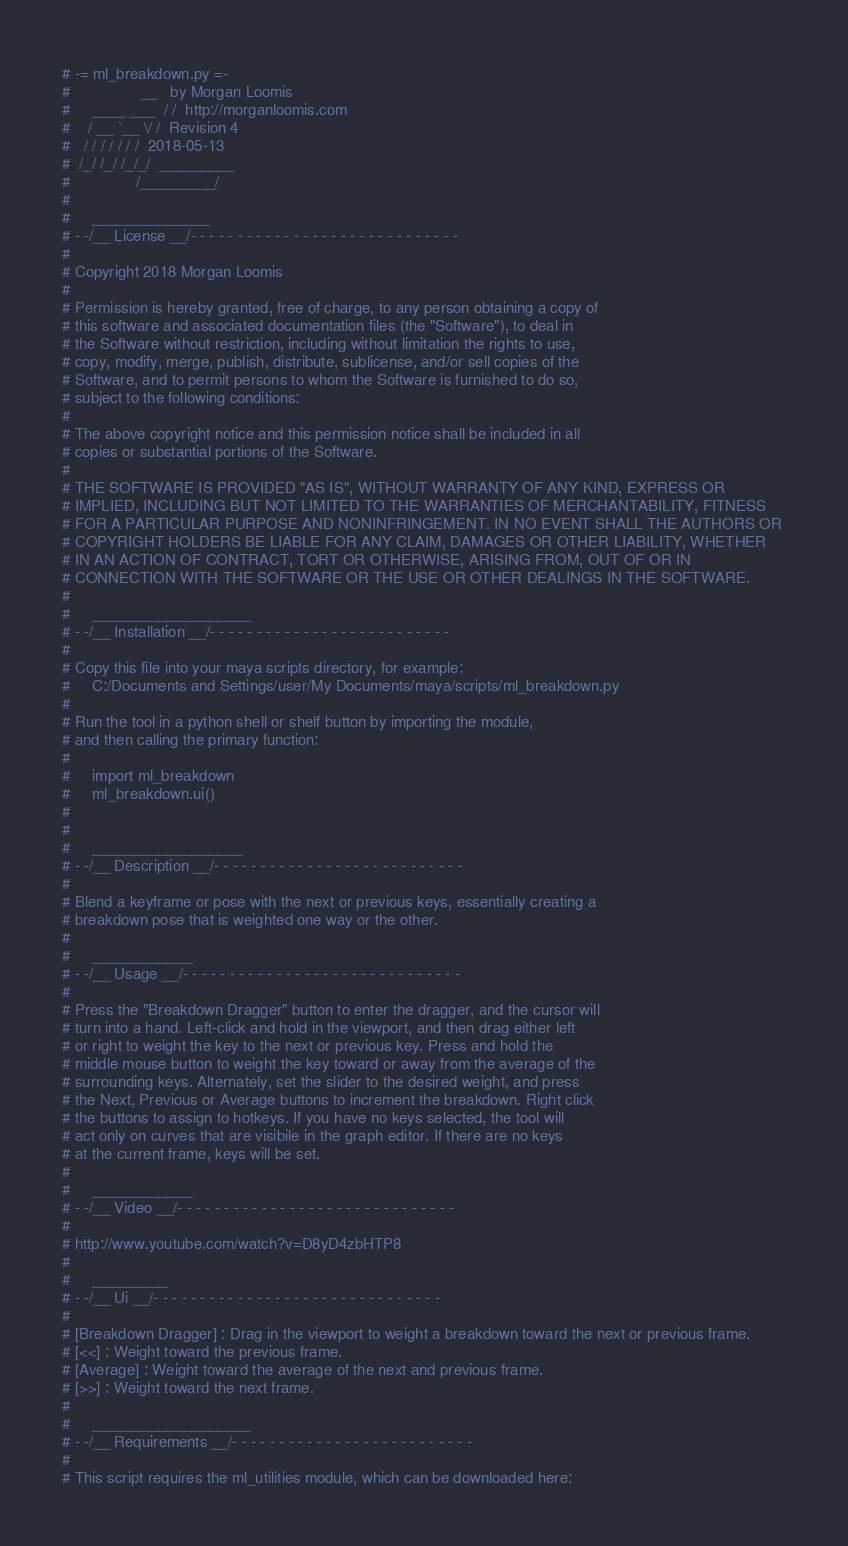Convert code to text. <code><loc_0><loc_0><loc_500><loc_500><_Python_># -= ml_breakdown.py =-
#                __   by Morgan Loomis
#     ____ ___  / /  http://morganloomis.com
#    / __ `__ \/ /  Revision 4
#   / / / / / / /  2018-05-13
#  /_/ /_/ /_/_/  _________
#               /_________/
# 
#     ______________
# - -/__ License __/- - - - - - - - - - - - - - - - - - - - - - - - - - - - - 
# 
# Copyright 2018 Morgan Loomis
# 
# Permission is hereby granted, free of charge, to any person obtaining a copy of 
# this software and associated documentation files (the "Software"), to deal in 
# the Software without restriction, including without limitation the rights to use, 
# copy, modify, merge, publish, distribute, sublicense, and/or sell copies of the 
# Software, and to permit persons to whom the Software is furnished to do so, 
# subject to the following conditions:
# 
# The above copyright notice and this permission notice shall be included in all 
# copies or substantial portions of the Software.
# 
# THE SOFTWARE IS PROVIDED "AS IS", WITHOUT WARRANTY OF ANY KIND, EXPRESS OR 
# IMPLIED, INCLUDING BUT NOT LIMITED TO THE WARRANTIES OF MERCHANTABILITY, FITNESS 
# FOR A PARTICULAR PURPOSE AND NONINFRINGEMENT. IN NO EVENT SHALL THE AUTHORS OR 
# COPYRIGHT HOLDERS BE LIABLE FOR ANY CLAIM, DAMAGES OR OTHER LIABILITY, WHETHER 
# IN AN ACTION OF CONTRACT, TORT OR OTHERWISE, ARISING FROM, OUT OF OR IN 
# CONNECTION WITH THE SOFTWARE OR THE USE OR OTHER DEALINGS IN THE SOFTWARE.
# 
#     ___________________
# - -/__ Installation __/- - - - - - - - - - - - - - - - - - - - - - - - - - 
# 
# Copy this file into your maya scripts directory, for example:
#     C:/Documents and Settings/user/My Documents/maya/scripts/ml_breakdown.py
# 
# Run the tool in a python shell or shelf button by importing the module, 
# and then calling the primary function:
# 
#     import ml_breakdown
#     ml_breakdown.ui()
# 
# 
#     __________________
# - -/__ Description __/- - - - - - - - - - - - - - - - - - - - - - - - - - - 
# 
# Blend a keyframe or pose with the next or previous keys, essentially creating a
# breakdown pose that is weighted one way or the other.
# 
#     ____________
# - -/__ Usage __/- - - - - - - - - - - - - - - - - - - - - - - - - - - - - - 
# 
# Press the "Breakdown Dragger" button to enter the dragger, and the cursor will
# turn into a hand. Left-click and hold in the viewport, and then drag either left
# or right to weight the key to the next or previous key. Press and hold the
# middle mouse button to weight the key toward or away from the average of the
# surrounding keys. Alternately, set the slider to the desired weight, and press
# the Next, Previous or Average buttons to increment the breakdown. Right click
# the buttons to assign to hotkeys. If you have no keys selected, the tool will
# act only on curves that are visibile in the graph editor. If there are no keys
# at the current frame, keys will be set.
# 
#     ____________
# - -/__ Video __/- - - - - - - - - - - - - - - - - - - - - - - - - - - - - - 
# 
# http://www.youtube.com/watch?v=D8yD4zbHTP8
# 
#     _________
# - -/__ Ui __/- - - - - - - - - - - - - - - - - - - - - - - - - - - - - - - 
# 
# [Breakdown Dragger] : Drag in the viewport to weight a breakdown toward the next or previous frame.
# [<<] : Weight toward the previous frame.
# [Average] : Weight toward the average of the next and previous frame.
# [>>] : Weight toward the next frame.
# 
#     ___________________
# - -/__ Requirements __/- - - - - - - - - - - - - - - - - - - - - - - - - - 
# 
# This script requires the ml_utilities module, which can be downloaded here:</code> 